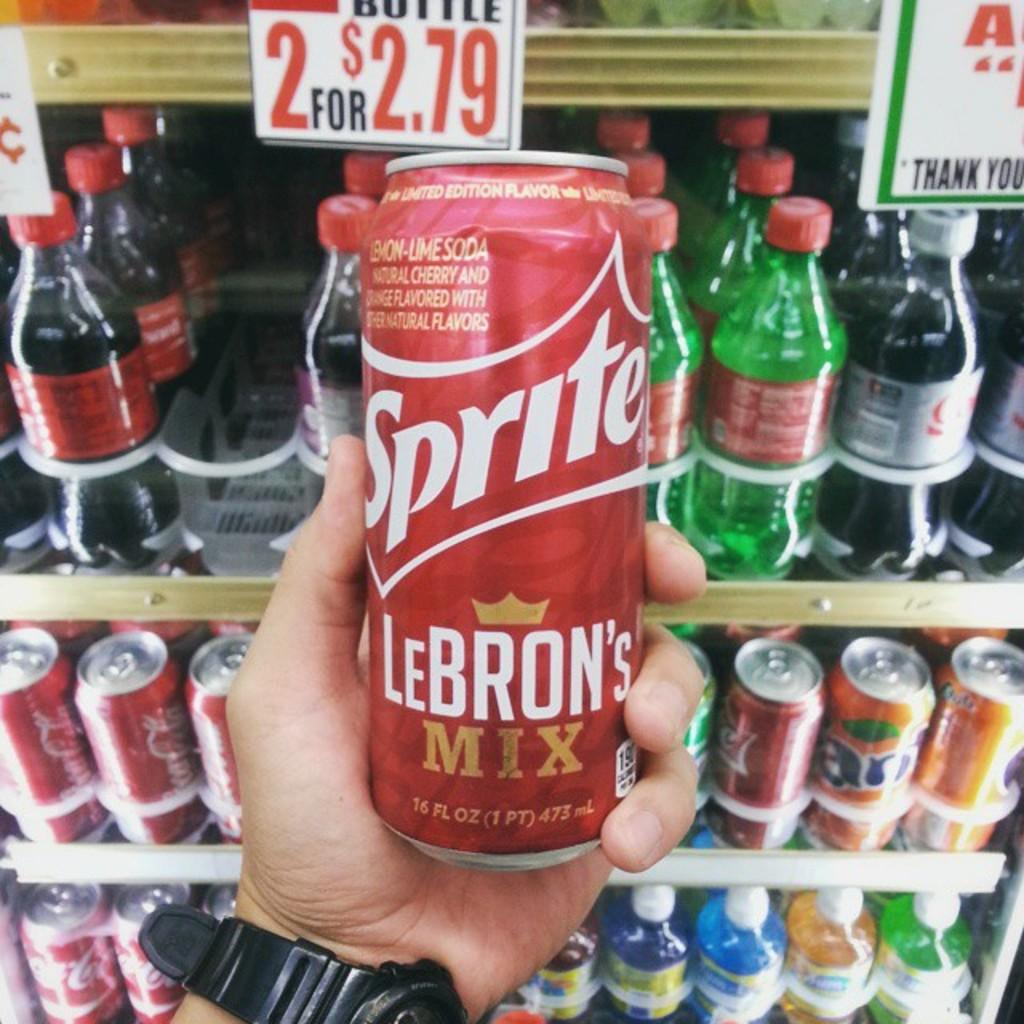<image>
Give a short and clear explanation of the subsequent image. A red Sprite can is a LeBron's mix version. 